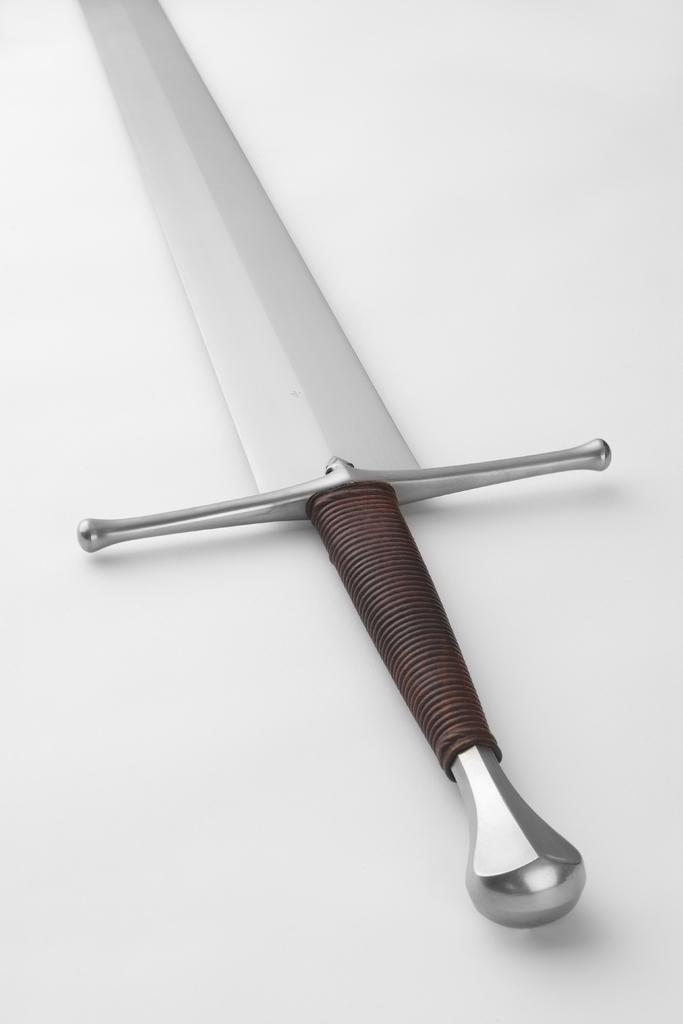Please provide a concise description of this image. In this image we can see a sword and the background is white. 